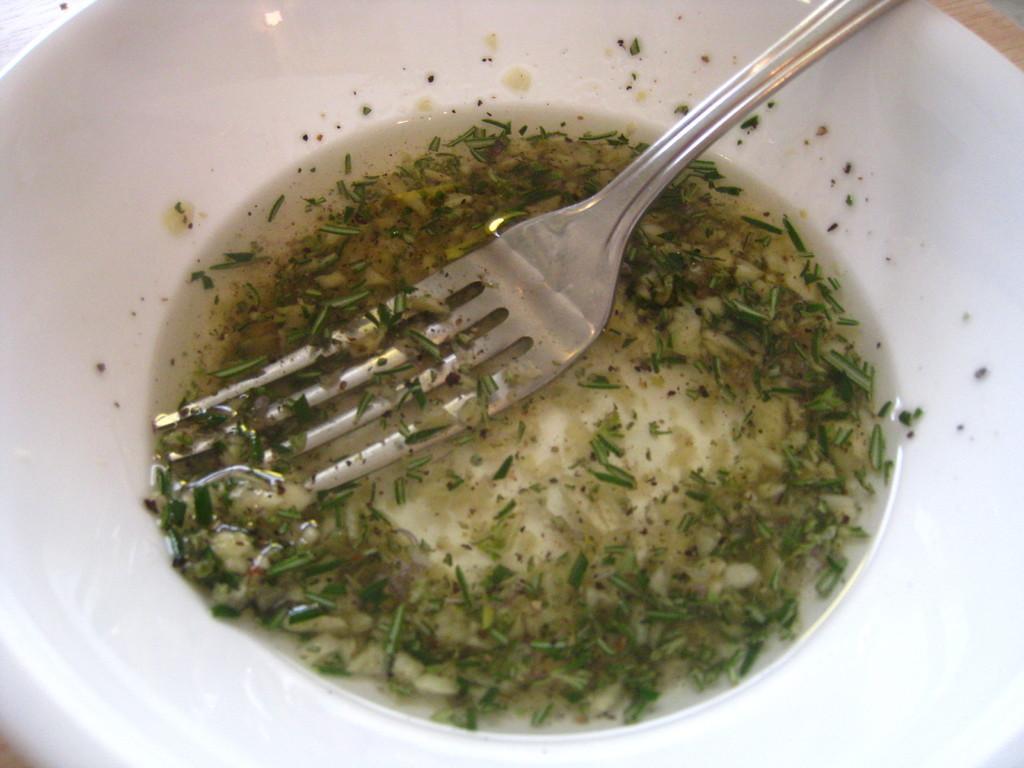How would you summarize this image in a sentence or two? In this image there is soup and a fork in a bowl, on the object. 